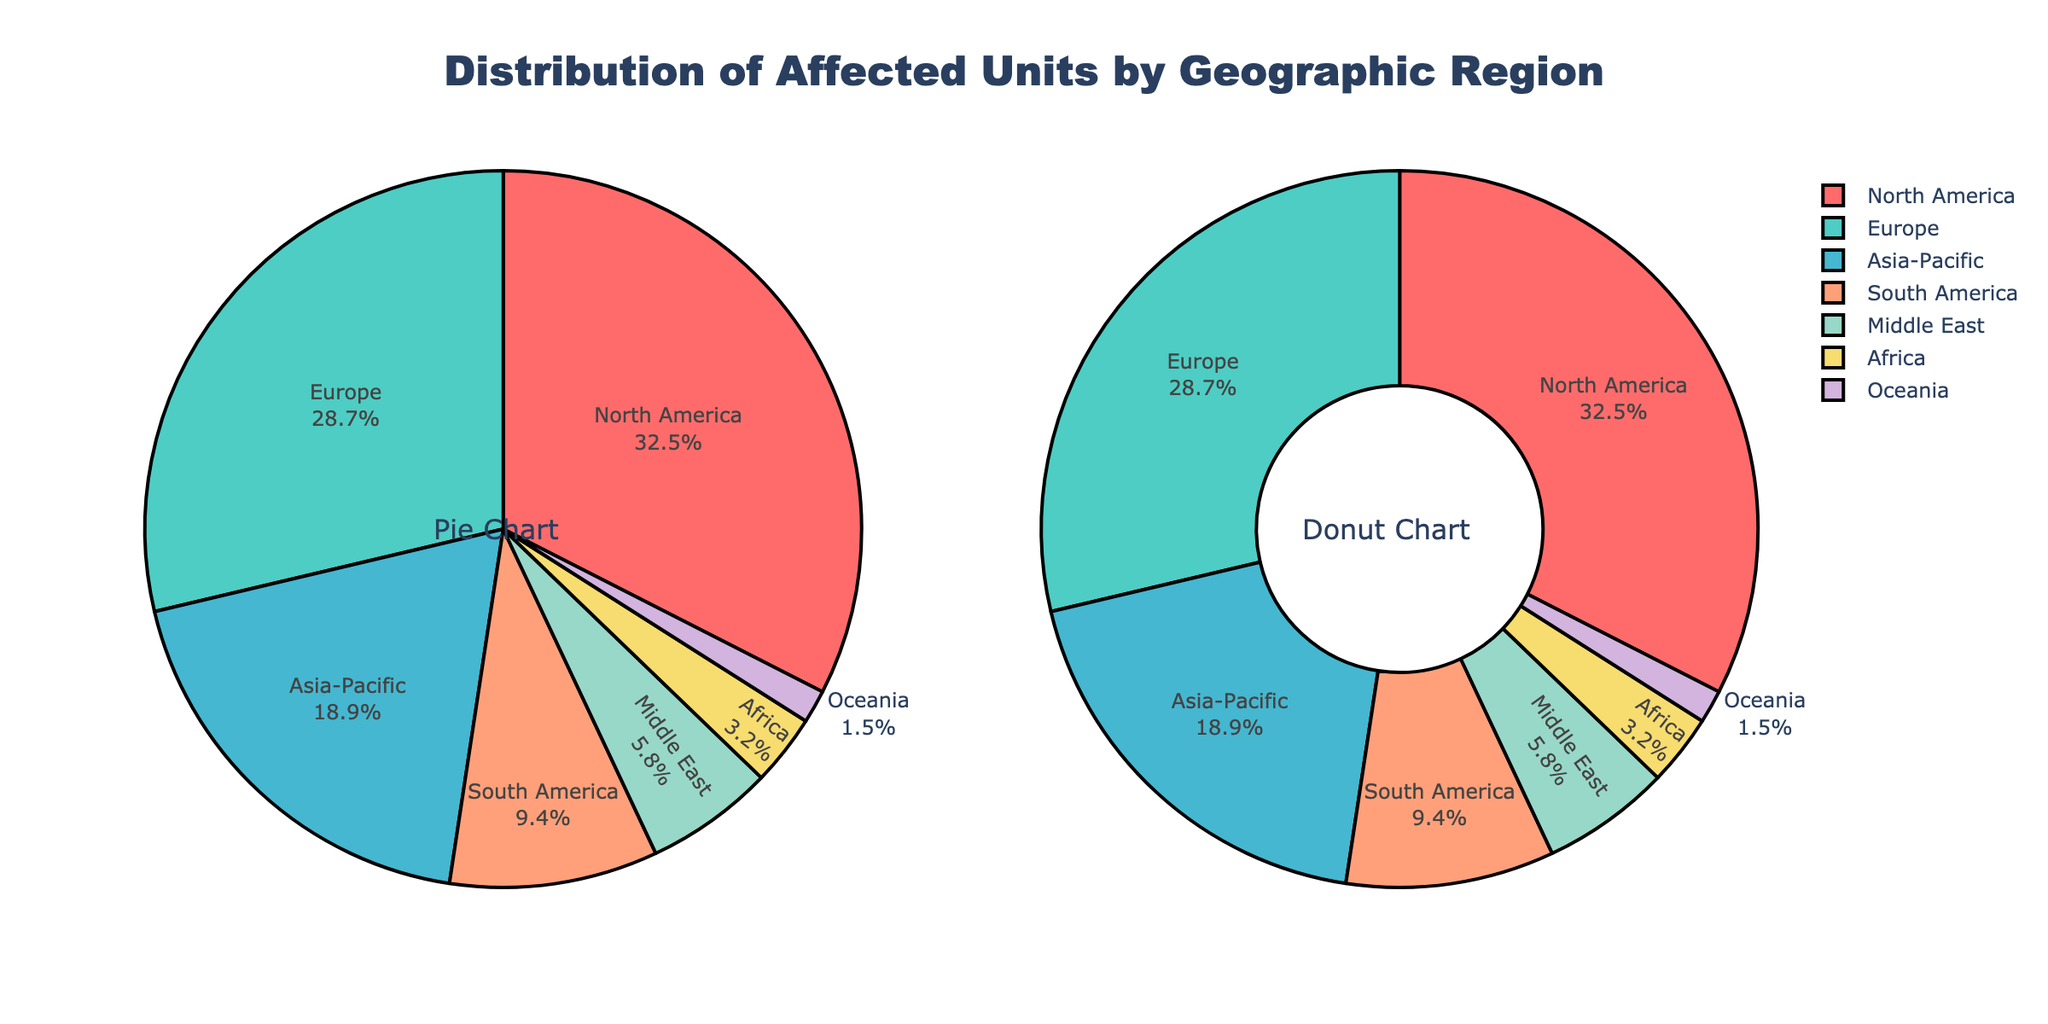What's the region with the highest percentage of affected units? The pie chart and donut chart both show North America having the largest slice, indicating the highest percentage of affected units.
Answer: North America What's the combined percentage of affected units in Europe and Asia-Pacific? The percentages for Europe (28.7%) and Asia-Pacific (18.9%) can be summed up: 28.7 + 18.9 = 47.6%.
Answer: 47.6% How much greater is the percentage of affected units in South America compared to Oceania? The percentage for South America is 9.4% and for Oceania is 1.5%. Subtract the latter from the former: 9.4 - 1.5 = 7.9%.
Answer: 7.9% Which regions have a combined percentage close to 50% when summed together? North America (32.5%) and Europe (28.7%) when summed: 32.5 + 28.7 = 61.2%, which is more than 50%. On the other hand, North America (32.5%) and Asia-Pacific (18.9%) total 32.5 + 18.9 = 51.4%, also over 50%. No combination of the next largest regions would get close to 50%.
Answer: No exact match What is the difference between the percentage of affected units in the Middle East and Africa? The chart shows Middle East with 5.8% and Africa with 3.2%. Subtract Africa's percentage from Middle East's: 5.8 - 3.2 = 2.6%.
Answer: 2.6% What's the total percentage of affected units in both the Middle East and Oceania? The pie chart and donut chart show 5.8% for Middle East and 1.5% for Oceania. Adding the two: 5.8 + 1.5 = 7.3%.
Answer: 7.3% Which region has the smallest slice on the pie chart and what is its percentage? The smallest slice on both the pie and donut charts belongs to Oceania, with a percentage of 1.5%.
Answer: Oceania, 1.5% Compare the percentage of affected units in North America to Europe. Which is greater and by how much? North America is 32.5% and Europe is 28.7%. Subtract Europe’s percentage from North America’s: 32.5 - 28.7 = 3.8%. Hence, North America's percentage is greater by 3.8%.
Answer: North America by 3.8% What can you infer by comparing the colored slices of South America and Middle East? South America has a larger dark orange slice than the Middle East's yellow slice, indicating South America has a higher percentage of affected units (9.4%) compared to the Middle East (5.8%).
Answer: South America has a higher percentage 